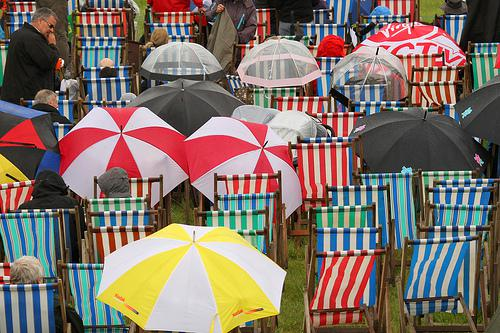Question: what type of chairs are these?
Choices:
A. Kitchen chairs.
B. Stadium seats.
C. Recliners.
D. Folding chairs.
Answer with the letter. Answer: D Question: where is this picture taken?
Choices:
A. On a beach.
B. At a pizza place.
C. The neighbor's party.
D. In the grass.
Answer with the letter. Answer: D Question: what objects are prominently visible in the picture?
Choices:
A. A dog and cat.
B. A bus and a pickup truck.
C. A couch and tv.
D. Umbrellas and chairs.
Answer with the letter. Answer: D Question: when is this picture taken?
Choices:
A. On his birthday.
B. Christmas day.
C. On a rainy day.
D. A Sunday.
Answer with the letter. Answer: C Question: who is standing on the left of the image?
Choices:
A. A man.
B. The child.
C. His team mate.
D. Santa Claus.
Answer with the letter. Answer: A Question: how many black umbrellas are visible?
Choices:
A. One.
B. Two.
C. Four.
D. Three.
Answer with the letter. Answer: D Question: who are in the chair?
Choices:
A. Santa and the child.
B. The story teller.
C. People.
D. The customers.
Answer with the letter. Answer: C 